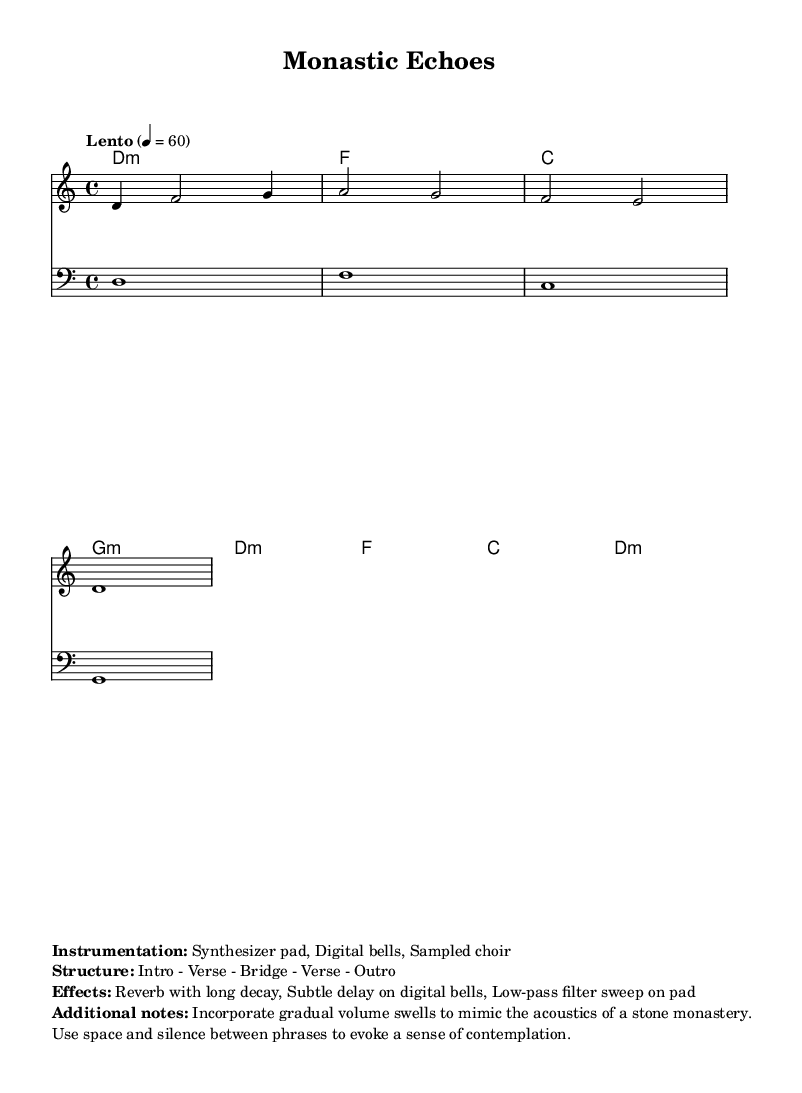What is the key signature of this music? The key signature is D Dorian, indicated by a "d" and the absence of sharps or flats in the score.
Answer: D Dorian What is the time signature of this music? The time signature is shown as 4/4, which means there are four beats per measure.
Answer: 4/4 What is the tempo marking for this piece? The tempo is marked "Lento" with a metronome marking of 60 beats per minute, defining a slow pace for the music.
Answer: Lento, 60 What instruments are used in this composition? The instrumentation is listed as "Synthesizer pad, Digital bells, Sampled choir," which indicates the electronic nature of the arrangement.
Answer: Synthesizer pad, Digital bells, Sampled choir How many sections are in the structure of the piece? The structure includes an "Intro - Verse - Bridge - Verse - Outro," which totals five distinct sections.
Answer: Five What type of harmony is employed in the progression? The harmony consists mainly of triads, such as "d:m", "f", and "g:m," indicating a combination of minor and major chords.
Answer: Triads What effect is suggested to mimic a monastery's acoustics? The notes recommend "gradual volume swells," which are designed to simulate the reverb of a stone environment.
Answer: Gradual volume swells 